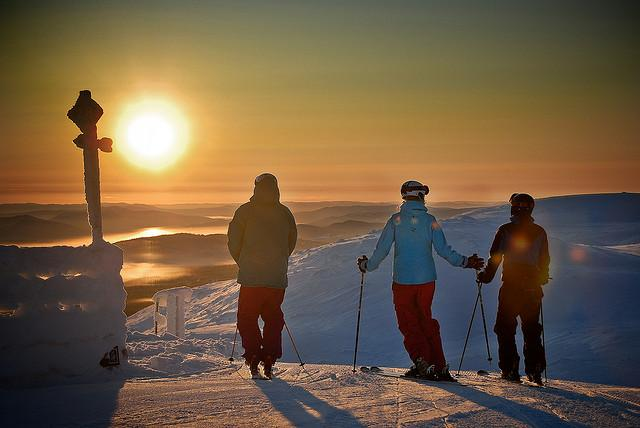What are the skiers watching?

Choices:
A) moon
B) sun
C) stars
D) clouds sun 